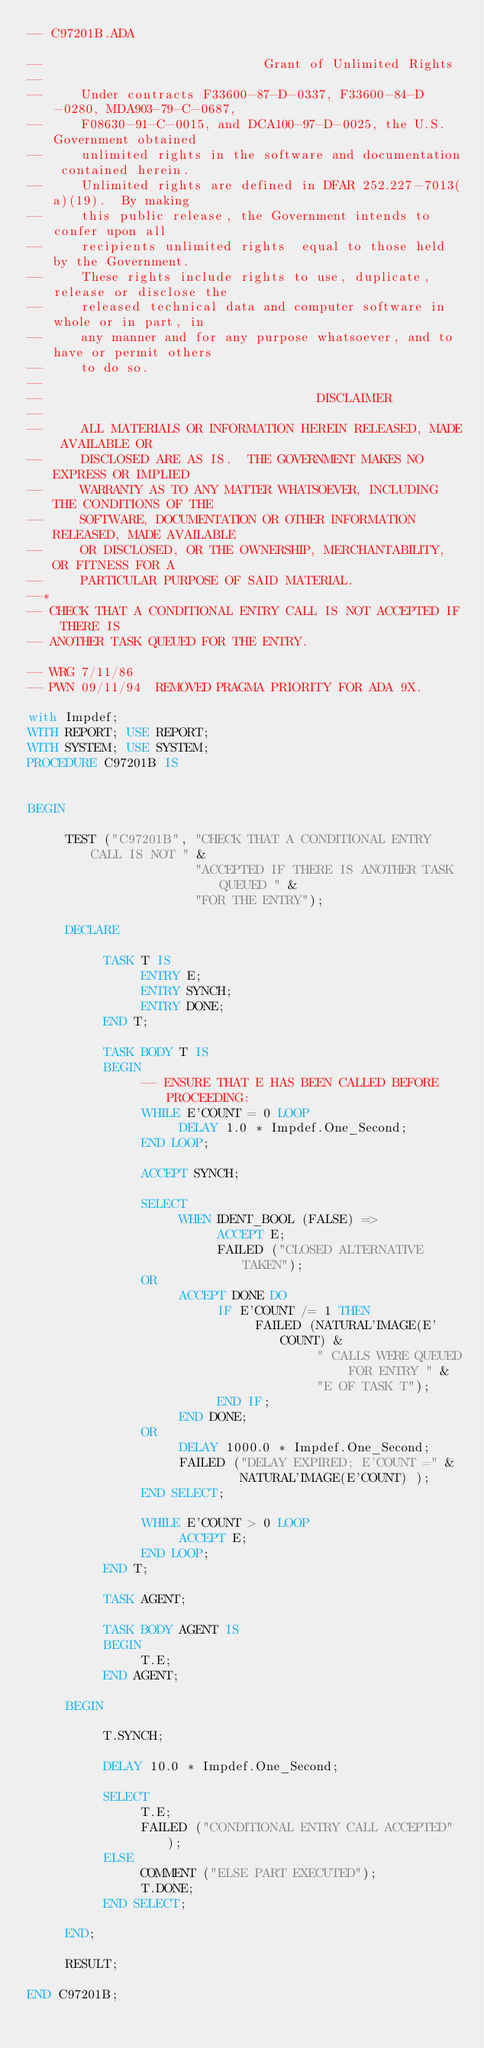Convert code to text. <code><loc_0><loc_0><loc_500><loc_500><_Ada_>-- C97201B.ADA

--                             Grant of Unlimited Rights
--
--     Under contracts F33600-87-D-0337, F33600-84-D-0280, MDA903-79-C-0687,
--     F08630-91-C-0015, and DCA100-97-D-0025, the U.S. Government obtained 
--     unlimited rights in the software and documentation contained herein.
--     Unlimited rights are defined in DFAR 252.227-7013(a)(19).  By making 
--     this public release, the Government intends to confer upon all 
--     recipients unlimited rights  equal to those held by the Government.  
--     These rights include rights to use, duplicate, release or disclose the 
--     released technical data and computer software in whole or in part, in 
--     any manner and for any purpose whatsoever, and to have or permit others 
--     to do so.
--
--                                    DISCLAIMER
--
--     ALL MATERIALS OR INFORMATION HEREIN RELEASED, MADE AVAILABLE OR
--     DISCLOSED ARE AS IS.  THE GOVERNMENT MAKES NO EXPRESS OR IMPLIED 
--     WARRANTY AS TO ANY MATTER WHATSOEVER, INCLUDING THE CONDITIONS OF THE
--     SOFTWARE, DOCUMENTATION OR OTHER INFORMATION RELEASED, MADE AVAILABLE 
--     OR DISCLOSED, OR THE OWNERSHIP, MERCHANTABILITY, OR FITNESS FOR A
--     PARTICULAR PURPOSE OF SAID MATERIAL.
--*
-- CHECK THAT A CONDITIONAL ENTRY CALL IS NOT ACCEPTED IF THERE IS
-- ANOTHER TASK QUEUED FOR THE ENTRY.

-- WRG 7/11/86
-- PWN 09/11/94  REMOVED PRAGMA PRIORITY FOR ADA 9X.

with Impdef;
WITH REPORT; USE REPORT;
WITH SYSTEM; USE SYSTEM;
PROCEDURE C97201B IS


BEGIN

     TEST ("C97201B", "CHECK THAT A CONDITIONAL ENTRY CALL IS NOT " &
                      "ACCEPTED IF THERE IS ANOTHER TASK QUEUED " &
                      "FOR THE ENTRY");

     DECLARE

          TASK T IS
               ENTRY E;
               ENTRY SYNCH;
               ENTRY DONE;
          END T;

          TASK BODY T IS
          BEGIN
               -- ENSURE THAT E HAS BEEN CALLED BEFORE PROCEEDING:
               WHILE E'COUNT = 0 LOOP
                    DELAY 1.0 * Impdef.One_Second;
               END LOOP;

               ACCEPT SYNCH;

               SELECT
                    WHEN IDENT_BOOL (FALSE) =>
                         ACCEPT E;
                         FAILED ("CLOSED ALTERNATIVE TAKEN");
               OR
                    ACCEPT DONE DO
                         IF E'COUNT /= 1 THEN
                              FAILED (NATURAL'IMAGE(E'COUNT) &
                                      " CALLS WERE QUEUED FOR ENTRY " &
                                      "E OF TASK T");
                         END IF;
                    END DONE;
               OR
                    DELAY 1000.0 * Impdef.One_Second;
                    FAILED ("DELAY EXPIRED; E'COUNT =" &
                            NATURAL'IMAGE(E'COUNT) );
               END SELECT;

               WHILE E'COUNT > 0 LOOP
                    ACCEPT E;
               END LOOP;
          END T;

          TASK AGENT;

          TASK BODY AGENT IS
          BEGIN
               T.E;
          END AGENT;

     BEGIN

          T.SYNCH;

          DELAY 10.0 * Impdef.One_Second;

          SELECT
               T.E;
               FAILED ("CONDITIONAL ENTRY CALL ACCEPTED" );
          ELSE
               COMMENT ("ELSE PART EXECUTED");
               T.DONE;
          END SELECT;

     END;

     RESULT;

END C97201B;
</code> 